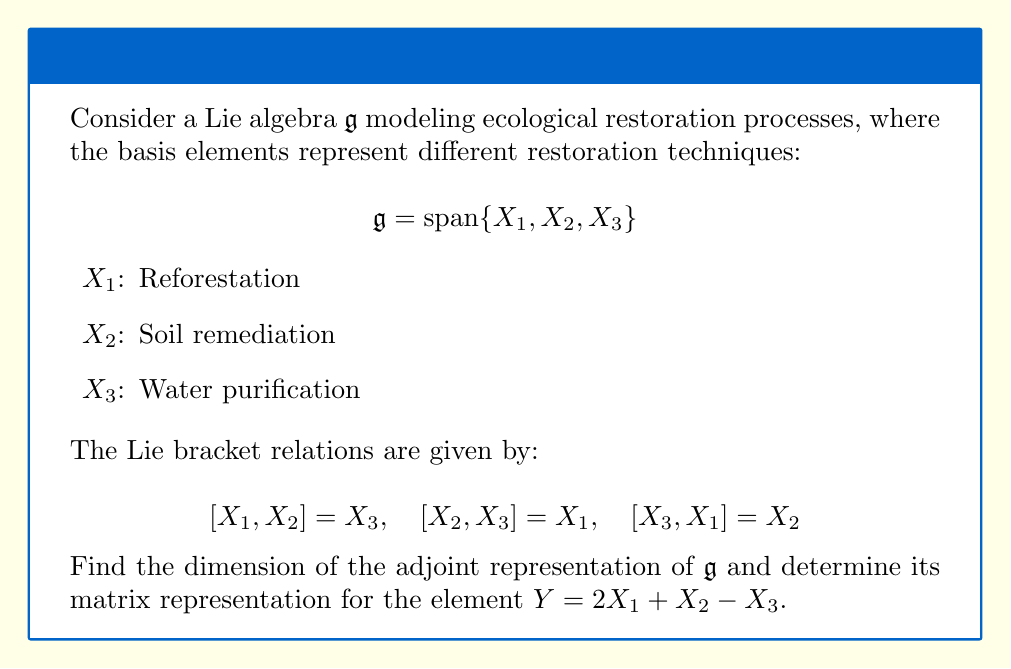Show me your answer to this math problem. Let's approach this step-by-step:

1) The adjoint representation of a Lie algebra $\mathfrak{g}$ is a linear map $\text{ad}: \mathfrak{g} \rightarrow \text{End}(\mathfrak{g})$ defined by $\text{ad}_X(Y) = [X,Y]$ for all $X,Y \in \mathfrak{g}$.

2) The dimension of the adjoint representation is equal to the dimension of $\mathfrak{g}$ itself. Here, $\dim(\mathfrak{g}) = 3$.

3) To find the matrix representation of $\text{ad}_Y$, we need to compute $[Y,X_i]$ for $i=1,2,3$:

   $[Y,X_1] = [2X_1 + X_2 - X_3, X_1] = 2[X_1,X_1] + [X_2,X_1] - [X_3,X_1]$
            $= 0 - X_3 - X_2 = -X_2 - X_3$

   $[Y,X_2] = [2X_1 + X_2 - X_3, X_2] = 2[X_1,X_2] + [X_2,X_2] - [X_3,X_2]$
            $= 2X_3 + 0 - (-X_1) = 2X_3 + X_1$

   $[Y,X_3] = [2X_1 + X_2 - X_3, X_3] = 2[X_1,X_3] + [X_2,X_3] - [X_3,X_3]$
            $= 2(-X_2) + X_1 + 0 = X_1 - 2X_2$

4) Now we can write the matrix representation of $\text{ad}_Y$ with respect to the basis $\{X_1, X_2, X_3\}$:

   $$\text{ad}_Y = \begin{pmatrix}
   0 & 1 & 1 \\
   -1 & 0 & -2 \\
   -1 & 2 & 0
   \end{pmatrix}$$
Answer: Dimension: 3; Matrix representation: $\begin{pmatrix} 0 & 1 & 1 \\ -1 & 0 & -2 \\ -1 & 2 & 0 \end{pmatrix}$ 